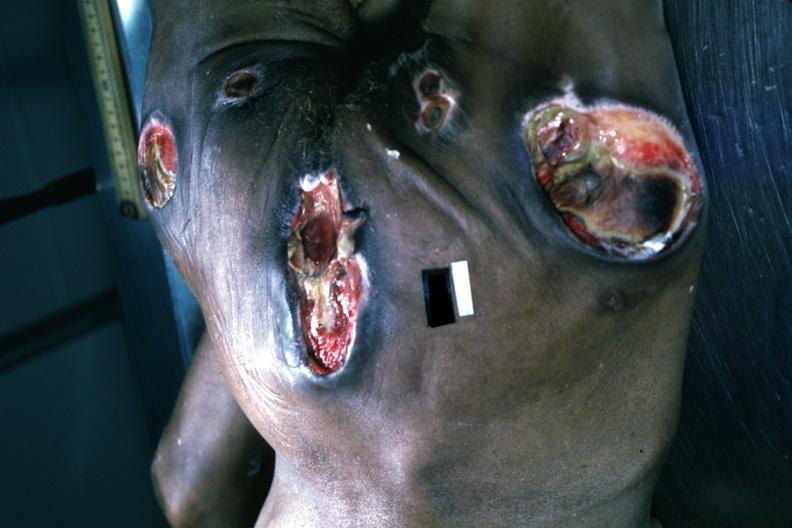does lymphangiomatosis generalized show large necrotic ulcers over sacrum buttocks and hips?
Answer the question using a single word or phrase. No 